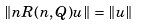<formula> <loc_0><loc_0><loc_500><loc_500>\| n R ( n , Q ) u \| = \| u \|</formula> 